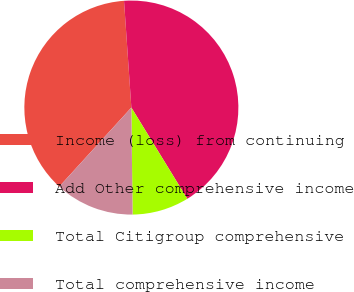Convert chart. <chart><loc_0><loc_0><loc_500><loc_500><pie_chart><fcel>Income (loss) from continuing<fcel>Add Other comprehensive income<fcel>Total Citigroup comprehensive<fcel>Total comprehensive income<nl><fcel>37.14%<fcel>42.34%<fcel>8.57%<fcel>11.95%<nl></chart> 